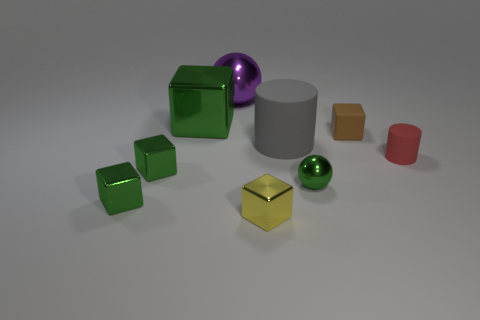Add 1 tiny yellow shiny blocks. How many objects exist? 10 Subtract all small yellow cubes. How many cubes are left? 4 Subtract all balls. How many objects are left? 7 Subtract 1 cylinders. How many cylinders are left? 1 Add 1 spheres. How many spheres are left? 3 Add 3 red things. How many red things exist? 4 Subtract all brown blocks. How many blocks are left? 4 Subtract 1 purple balls. How many objects are left? 8 Subtract all blue cylinders. Subtract all yellow spheres. How many cylinders are left? 2 Subtract all yellow blocks. How many yellow cylinders are left? 0 